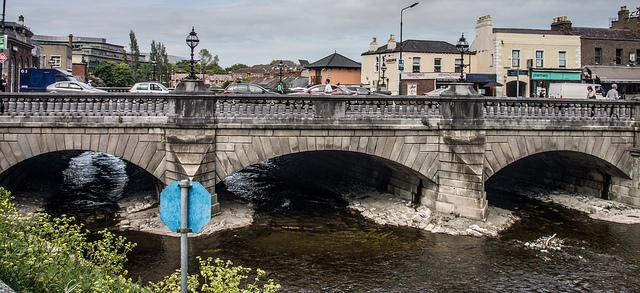What kind of river channel it is? Please explain your reasoning. canal. The river is a canal. 